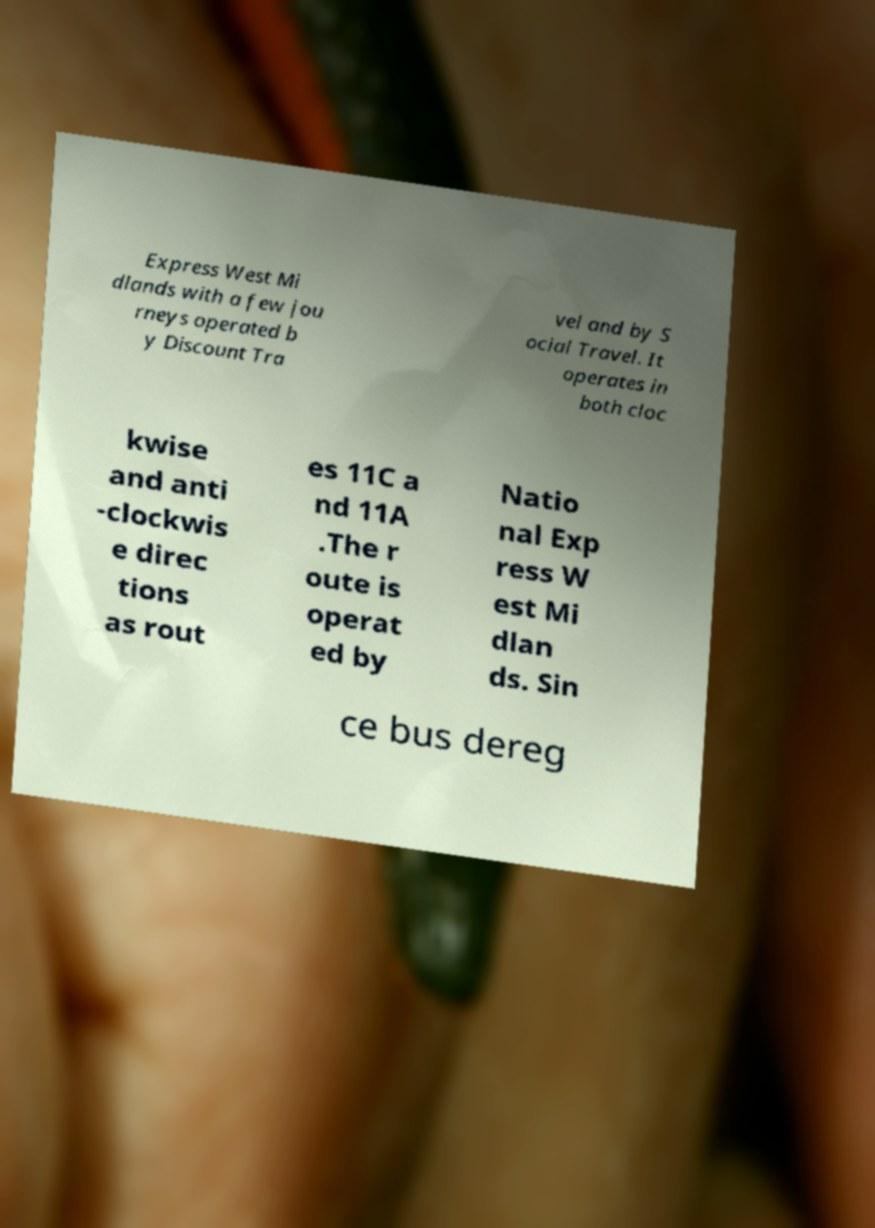I need the written content from this picture converted into text. Can you do that? Express West Mi dlands with a few jou rneys operated b y Discount Tra vel and by S ocial Travel. It operates in both cloc kwise and anti -clockwis e direc tions as rout es 11C a nd 11A .The r oute is operat ed by Natio nal Exp ress W est Mi dlan ds. Sin ce bus dereg 